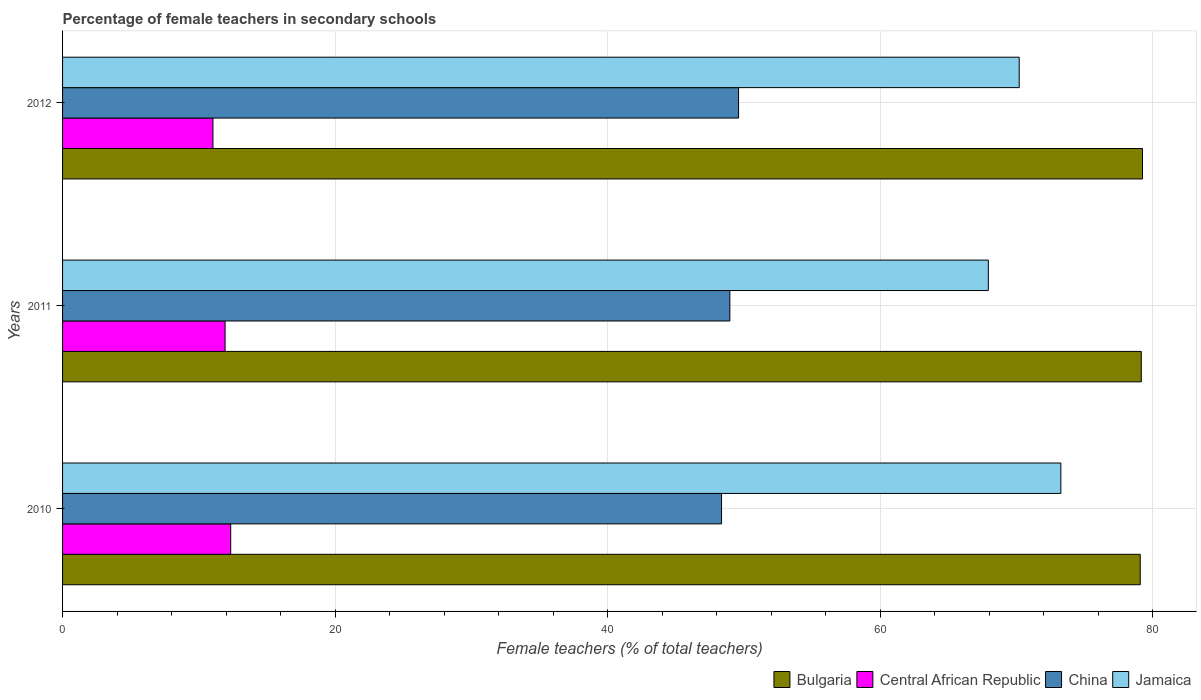How many groups of bars are there?
Offer a terse response. 3. Are the number of bars per tick equal to the number of legend labels?
Ensure brevity in your answer.  Yes. Are the number of bars on each tick of the Y-axis equal?
Keep it short and to the point. Yes. How many bars are there on the 2nd tick from the top?
Your answer should be compact. 4. How many bars are there on the 2nd tick from the bottom?
Make the answer very short. 4. What is the percentage of female teachers in China in 2011?
Keep it short and to the point. 48.98. Across all years, what is the maximum percentage of female teachers in Jamaica?
Your response must be concise. 73.27. Across all years, what is the minimum percentage of female teachers in China?
Offer a very short reply. 48.37. What is the total percentage of female teachers in Jamaica in the graph?
Your response must be concise. 211.44. What is the difference between the percentage of female teachers in China in 2010 and that in 2011?
Offer a very short reply. -0.61. What is the difference between the percentage of female teachers in China in 2011 and the percentage of female teachers in Bulgaria in 2012?
Provide a succinct answer. -30.29. What is the average percentage of female teachers in Jamaica per year?
Make the answer very short. 70.48. In the year 2010, what is the difference between the percentage of female teachers in China and percentage of female teachers in Bulgaria?
Provide a succinct answer. -30.73. What is the ratio of the percentage of female teachers in Jamaica in 2010 to that in 2012?
Your answer should be very brief. 1.04. Is the percentage of female teachers in Central African Republic in 2010 less than that in 2011?
Give a very brief answer. No. What is the difference between the highest and the second highest percentage of female teachers in Central African Republic?
Offer a terse response. 0.41. What is the difference between the highest and the lowest percentage of female teachers in China?
Offer a terse response. 1.25. Is it the case that in every year, the sum of the percentage of female teachers in Central African Republic and percentage of female teachers in China is greater than the sum of percentage of female teachers in Bulgaria and percentage of female teachers in Jamaica?
Your response must be concise. No. What does the 1st bar from the top in 2012 represents?
Your response must be concise. Jamaica. What does the 4th bar from the bottom in 2011 represents?
Provide a short and direct response. Jamaica. Is it the case that in every year, the sum of the percentage of female teachers in Bulgaria and percentage of female teachers in China is greater than the percentage of female teachers in Central African Republic?
Offer a terse response. Yes. Are all the bars in the graph horizontal?
Provide a short and direct response. Yes. Does the graph contain any zero values?
Your answer should be very brief. No. Where does the legend appear in the graph?
Your response must be concise. Bottom right. How are the legend labels stacked?
Your answer should be compact. Horizontal. What is the title of the graph?
Your answer should be very brief. Percentage of female teachers in secondary schools. What is the label or title of the X-axis?
Give a very brief answer. Female teachers (% of total teachers). What is the Female teachers (% of total teachers) of Bulgaria in 2010?
Ensure brevity in your answer.  79.1. What is the Female teachers (% of total teachers) in Central African Republic in 2010?
Provide a succinct answer. 12.34. What is the Female teachers (% of total teachers) of China in 2010?
Your answer should be very brief. 48.37. What is the Female teachers (% of total teachers) in Jamaica in 2010?
Ensure brevity in your answer.  73.27. What is the Female teachers (% of total teachers) of Bulgaria in 2011?
Your answer should be compact. 79.18. What is the Female teachers (% of total teachers) in Central African Republic in 2011?
Offer a terse response. 11.93. What is the Female teachers (% of total teachers) in China in 2011?
Make the answer very short. 48.98. What is the Female teachers (% of total teachers) of Jamaica in 2011?
Offer a very short reply. 67.95. What is the Female teachers (% of total teachers) in Bulgaria in 2012?
Your answer should be compact. 79.27. What is the Female teachers (% of total teachers) in Central African Republic in 2012?
Provide a succinct answer. 11.04. What is the Female teachers (% of total teachers) of China in 2012?
Keep it short and to the point. 49.62. What is the Female teachers (% of total teachers) in Jamaica in 2012?
Keep it short and to the point. 70.22. Across all years, what is the maximum Female teachers (% of total teachers) of Bulgaria?
Your answer should be compact. 79.27. Across all years, what is the maximum Female teachers (% of total teachers) in Central African Republic?
Your answer should be very brief. 12.34. Across all years, what is the maximum Female teachers (% of total teachers) of China?
Provide a short and direct response. 49.62. Across all years, what is the maximum Female teachers (% of total teachers) in Jamaica?
Your answer should be very brief. 73.27. Across all years, what is the minimum Female teachers (% of total teachers) of Bulgaria?
Your answer should be very brief. 79.1. Across all years, what is the minimum Female teachers (% of total teachers) in Central African Republic?
Ensure brevity in your answer.  11.04. Across all years, what is the minimum Female teachers (% of total teachers) in China?
Give a very brief answer. 48.37. Across all years, what is the minimum Female teachers (% of total teachers) of Jamaica?
Your answer should be compact. 67.95. What is the total Female teachers (% of total teachers) in Bulgaria in the graph?
Provide a short and direct response. 237.54. What is the total Female teachers (% of total teachers) of Central African Republic in the graph?
Give a very brief answer. 35.31. What is the total Female teachers (% of total teachers) in China in the graph?
Provide a short and direct response. 146.97. What is the total Female teachers (% of total teachers) of Jamaica in the graph?
Your response must be concise. 211.44. What is the difference between the Female teachers (% of total teachers) of Bulgaria in 2010 and that in 2011?
Your response must be concise. -0.08. What is the difference between the Female teachers (% of total teachers) of Central African Republic in 2010 and that in 2011?
Make the answer very short. 0.41. What is the difference between the Female teachers (% of total teachers) in China in 2010 and that in 2011?
Make the answer very short. -0.61. What is the difference between the Female teachers (% of total teachers) of Jamaica in 2010 and that in 2011?
Keep it short and to the point. 5.32. What is the difference between the Female teachers (% of total teachers) of Bulgaria in 2010 and that in 2012?
Your response must be concise. -0.17. What is the difference between the Female teachers (% of total teachers) of Central African Republic in 2010 and that in 2012?
Offer a very short reply. 1.3. What is the difference between the Female teachers (% of total teachers) in China in 2010 and that in 2012?
Your response must be concise. -1.25. What is the difference between the Female teachers (% of total teachers) of Jamaica in 2010 and that in 2012?
Provide a short and direct response. 3.06. What is the difference between the Female teachers (% of total teachers) in Bulgaria in 2011 and that in 2012?
Keep it short and to the point. -0.09. What is the difference between the Female teachers (% of total teachers) in Central African Republic in 2011 and that in 2012?
Keep it short and to the point. 0.89. What is the difference between the Female teachers (% of total teachers) of China in 2011 and that in 2012?
Your answer should be compact. -0.64. What is the difference between the Female teachers (% of total teachers) in Jamaica in 2011 and that in 2012?
Your answer should be very brief. -2.26. What is the difference between the Female teachers (% of total teachers) in Bulgaria in 2010 and the Female teachers (% of total teachers) in Central African Republic in 2011?
Provide a succinct answer. 67.17. What is the difference between the Female teachers (% of total teachers) of Bulgaria in 2010 and the Female teachers (% of total teachers) of China in 2011?
Give a very brief answer. 30.12. What is the difference between the Female teachers (% of total teachers) of Bulgaria in 2010 and the Female teachers (% of total teachers) of Jamaica in 2011?
Provide a succinct answer. 11.15. What is the difference between the Female teachers (% of total teachers) of Central African Republic in 2010 and the Female teachers (% of total teachers) of China in 2011?
Your response must be concise. -36.64. What is the difference between the Female teachers (% of total teachers) of Central African Republic in 2010 and the Female teachers (% of total teachers) of Jamaica in 2011?
Keep it short and to the point. -55.61. What is the difference between the Female teachers (% of total teachers) in China in 2010 and the Female teachers (% of total teachers) in Jamaica in 2011?
Give a very brief answer. -19.58. What is the difference between the Female teachers (% of total teachers) in Bulgaria in 2010 and the Female teachers (% of total teachers) in Central African Republic in 2012?
Offer a very short reply. 68.06. What is the difference between the Female teachers (% of total teachers) in Bulgaria in 2010 and the Female teachers (% of total teachers) in China in 2012?
Make the answer very short. 29.48. What is the difference between the Female teachers (% of total teachers) in Bulgaria in 2010 and the Female teachers (% of total teachers) in Jamaica in 2012?
Your answer should be very brief. 8.88. What is the difference between the Female teachers (% of total teachers) in Central African Republic in 2010 and the Female teachers (% of total teachers) in China in 2012?
Provide a short and direct response. -37.28. What is the difference between the Female teachers (% of total teachers) in Central African Republic in 2010 and the Female teachers (% of total teachers) in Jamaica in 2012?
Give a very brief answer. -57.87. What is the difference between the Female teachers (% of total teachers) in China in 2010 and the Female teachers (% of total teachers) in Jamaica in 2012?
Offer a terse response. -21.85. What is the difference between the Female teachers (% of total teachers) of Bulgaria in 2011 and the Female teachers (% of total teachers) of Central African Republic in 2012?
Offer a terse response. 68.14. What is the difference between the Female teachers (% of total teachers) in Bulgaria in 2011 and the Female teachers (% of total teachers) in China in 2012?
Provide a succinct answer. 29.56. What is the difference between the Female teachers (% of total teachers) of Bulgaria in 2011 and the Female teachers (% of total teachers) of Jamaica in 2012?
Keep it short and to the point. 8.96. What is the difference between the Female teachers (% of total teachers) of Central African Republic in 2011 and the Female teachers (% of total teachers) of China in 2012?
Provide a short and direct response. -37.69. What is the difference between the Female teachers (% of total teachers) of Central African Republic in 2011 and the Female teachers (% of total teachers) of Jamaica in 2012?
Give a very brief answer. -58.29. What is the difference between the Female teachers (% of total teachers) of China in 2011 and the Female teachers (% of total teachers) of Jamaica in 2012?
Keep it short and to the point. -21.24. What is the average Female teachers (% of total teachers) in Bulgaria per year?
Provide a short and direct response. 79.18. What is the average Female teachers (% of total teachers) of Central African Republic per year?
Your answer should be compact. 11.77. What is the average Female teachers (% of total teachers) in China per year?
Ensure brevity in your answer.  48.99. What is the average Female teachers (% of total teachers) in Jamaica per year?
Give a very brief answer. 70.48. In the year 2010, what is the difference between the Female teachers (% of total teachers) in Bulgaria and Female teachers (% of total teachers) in Central African Republic?
Ensure brevity in your answer.  66.76. In the year 2010, what is the difference between the Female teachers (% of total teachers) in Bulgaria and Female teachers (% of total teachers) in China?
Offer a very short reply. 30.73. In the year 2010, what is the difference between the Female teachers (% of total teachers) of Bulgaria and Female teachers (% of total teachers) of Jamaica?
Offer a very short reply. 5.83. In the year 2010, what is the difference between the Female teachers (% of total teachers) in Central African Republic and Female teachers (% of total teachers) in China?
Offer a very short reply. -36.03. In the year 2010, what is the difference between the Female teachers (% of total teachers) in Central African Republic and Female teachers (% of total teachers) in Jamaica?
Your answer should be very brief. -60.93. In the year 2010, what is the difference between the Female teachers (% of total teachers) in China and Female teachers (% of total teachers) in Jamaica?
Offer a terse response. -24.91. In the year 2011, what is the difference between the Female teachers (% of total teachers) of Bulgaria and Female teachers (% of total teachers) of Central African Republic?
Your answer should be very brief. 67.25. In the year 2011, what is the difference between the Female teachers (% of total teachers) in Bulgaria and Female teachers (% of total teachers) in China?
Offer a very short reply. 30.2. In the year 2011, what is the difference between the Female teachers (% of total teachers) in Bulgaria and Female teachers (% of total teachers) in Jamaica?
Offer a very short reply. 11.23. In the year 2011, what is the difference between the Female teachers (% of total teachers) in Central African Republic and Female teachers (% of total teachers) in China?
Provide a short and direct response. -37.05. In the year 2011, what is the difference between the Female teachers (% of total teachers) in Central African Republic and Female teachers (% of total teachers) in Jamaica?
Make the answer very short. -56.02. In the year 2011, what is the difference between the Female teachers (% of total teachers) of China and Female teachers (% of total teachers) of Jamaica?
Keep it short and to the point. -18.97. In the year 2012, what is the difference between the Female teachers (% of total teachers) in Bulgaria and Female teachers (% of total teachers) in Central African Republic?
Make the answer very short. 68.23. In the year 2012, what is the difference between the Female teachers (% of total teachers) in Bulgaria and Female teachers (% of total teachers) in China?
Offer a very short reply. 29.65. In the year 2012, what is the difference between the Female teachers (% of total teachers) of Bulgaria and Female teachers (% of total teachers) of Jamaica?
Keep it short and to the point. 9.05. In the year 2012, what is the difference between the Female teachers (% of total teachers) of Central African Republic and Female teachers (% of total teachers) of China?
Your answer should be compact. -38.58. In the year 2012, what is the difference between the Female teachers (% of total teachers) of Central African Republic and Female teachers (% of total teachers) of Jamaica?
Give a very brief answer. -59.18. In the year 2012, what is the difference between the Female teachers (% of total teachers) in China and Female teachers (% of total teachers) in Jamaica?
Provide a succinct answer. -20.6. What is the ratio of the Female teachers (% of total teachers) of Bulgaria in 2010 to that in 2011?
Ensure brevity in your answer.  1. What is the ratio of the Female teachers (% of total teachers) of Central African Republic in 2010 to that in 2011?
Your answer should be very brief. 1.03. What is the ratio of the Female teachers (% of total teachers) of China in 2010 to that in 2011?
Your answer should be compact. 0.99. What is the ratio of the Female teachers (% of total teachers) in Jamaica in 2010 to that in 2011?
Your answer should be compact. 1.08. What is the ratio of the Female teachers (% of total teachers) in Central African Republic in 2010 to that in 2012?
Your response must be concise. 1.12. What is the ratio of the Female teachers (% of total teachers) of China in 2010 to that in 2012?
Offer a terse response. 0.97. What is the ratio of the Female teachers (% of total teachers) of Jamaica in 2010 to that in 2012?
Your response must be concise. 1.04. What is the ratio of the Female teachers (% of total teachers) in Bulgaria in 2011 to that in 2012?
Provide a succinct answer. 1. What is the ratio of the Female teachers (% of total teachers) of Central African Republic in 2011 to that in 2012?
Your answer should be very brief. 1.08. What is the ratio of the Female teachers (% of total teachers) of China in 2011 to that in 2012?
Your answer should be compact. 0.99. What is the ratio of the Female teachers (% of total teachers) of Jamaica in 2011 to that in 2012?
Ensure brevity in your answer.  0.97. What is the difference between the highest and the second highest Female teachers (% of total teachers) in Bulgaria?
Your response must be concise. 0.09. What is the difference between the highest and the second highest Female teachers (% of total teachers) of Central African Republic?
Keep it short and to the point. 0.41. What is the difference between the highest and the second highest Female teachers (% of total teachers) of China?
Make the answer very short. 0.64. What is the difference between the highest and the second highest Female teachers (% of total teachers) in Jamaica?
Give a very brief answer. 3.06. What is the difference between the highest and the lowest Female teachers (% of total teachers) in Bulgaria?
Keep it short and to the point. 0.17. What is the difference between the highest and the lowest Female teachers (% of total teachers) of Central African Republic?
Keep it short and to the point. 1.3. What is the difference between the highest and the lowest Female teachers (% of total teachers) of China?
Provide a succinct answer. 1.25. What is the difference between the highest and the lowest Female teachers (% of total teachers) in Jamaica?
Your answer should be compact. 5.32. 